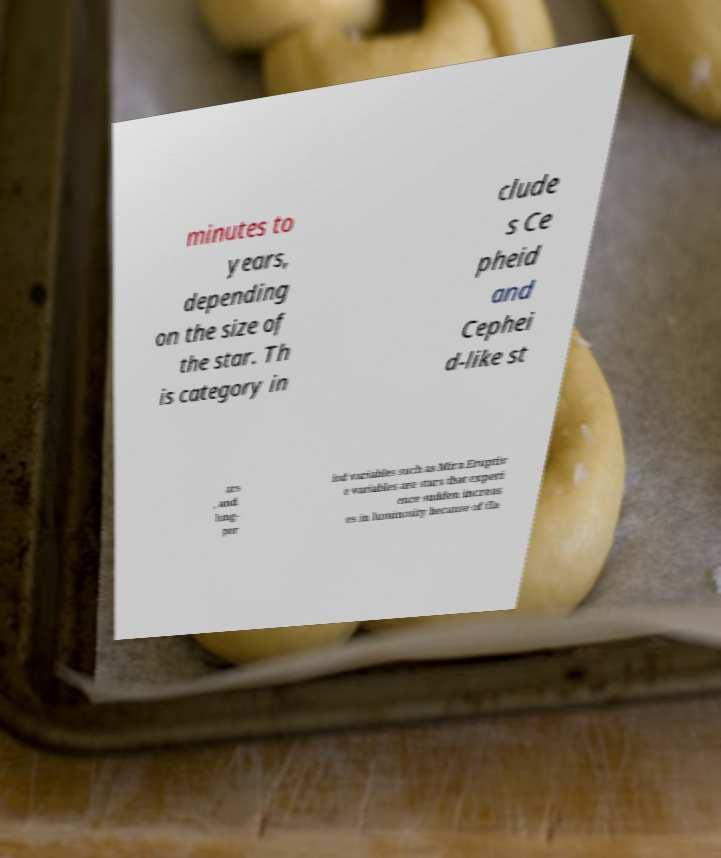Please read and relay the text visible in this image. What does it say? minutes to years, depending on the size of the star. Th is category in clude s Ce pheid and Cephei d-like st ars , and long- per iod variables such as Mira.Eruptiv e variables are stars that experi ence sudden increas es in luminosity because of fla 